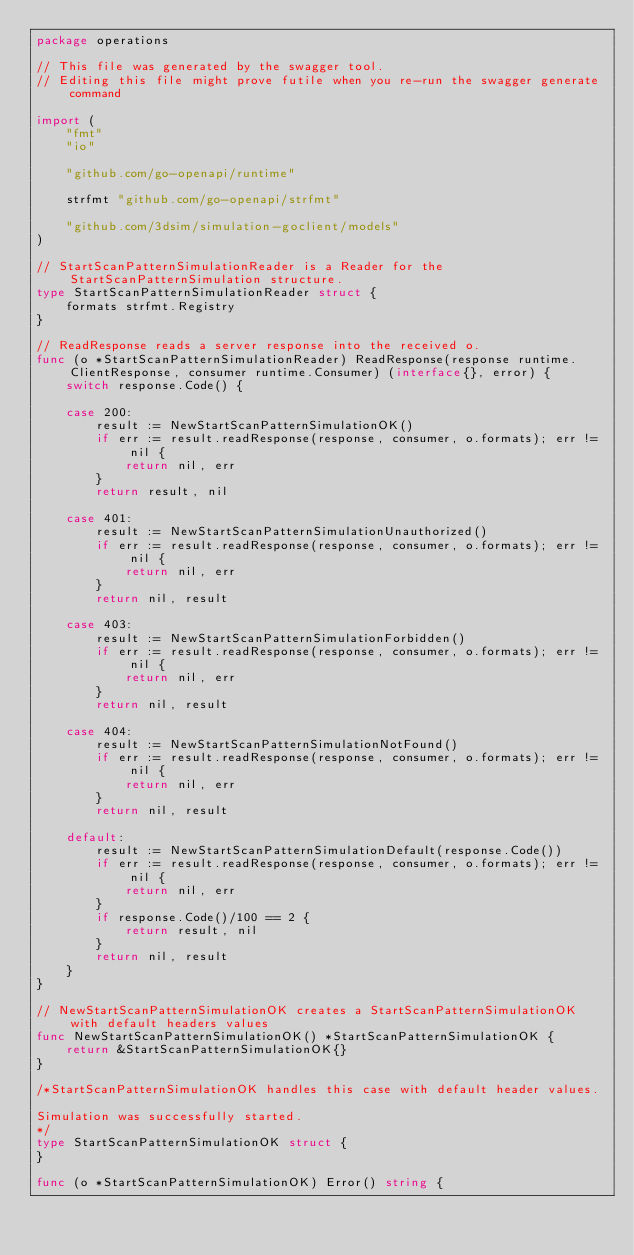Convert code to text. <code><loc_0><loc_0><loc_500><loc_500><_Go_>package operations

// This file was generated by the swagger tool.
// Editing this file might prove futile when you re-run the swagger generate command

import (
	"fmt"
	"io"

	"github.com/go-openapi/runtime"

	strfmt "github.com/go-openapi/strfmt"

	"github.com/3dsim/simulation-goclient/models"
)

// StartScanPatternSimulationReader is a Reader for the StartScanPatternSimulation structure.
type StartScanPatternSimulationReader struct {
	formats strfmt.Registry
}

// ReadResponse reads a server response into the received o.
func (o *StartScanPatternSimulationReader) ReadResponse(response runtime.ClientResponse, consumer runtime.Consumer) (interface{}, error) {
	switch response.Code() {

	case 200:
		result := NewStartScanPatternSimulationOK()
		if err := result.readResponse(response, consumer, o.formats); err != nil {
			return nil, err
		}
		return result, nil

	case 401:
		result := NewStartScanPatternSimulationUnauthorized()
		if err := result.readResponse(response, consumer, o.formats); err != nil {
			return nil, err
		}
		return nil, result

	case 403:
		result := NewStartScanPatternSimulationForbidden()
		if err := result.readResponse(response, consumer, o.formats); err != nil {
			return nil, err
		}
		return nil, result

	case 404:
		result := NewStartScanPatternSimulationNotFound()
		if err := result.readResponse(response, consumer, o.formats); err != nil {
			return nil, err
		}
		return nil, result

	default:
		result := NewStartScanPatternSimulationDefault(response.Code())
		if err := result.readResponse(response, consumer, o.formats); err != nil {
			return nil, err
		}
		if response.Code()/100 == 2 {
			return result, nil
		}
		return nil, result
	}
}

// NewStartScanPatternSimulationOK creates a StartScanPatternSimulationOK with default headers values
func NewStartScanPatternSimulationOK() *StartScanPatternSimulationOK {
	return &StartScanPatternSimulationOK{}
}

/*StartScanPatternSimulationOK handles this case with default header values.

Simulation was successfully started.
*/
type StartScanPatternSimulationOK struct {
}

func (o *StartScanPatternSimulationOK) Error() string {</code> 